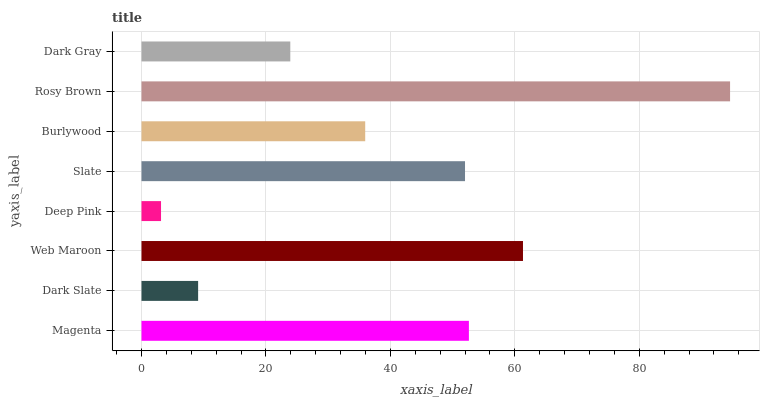Is Deep Pink the minimum?
Answer yes or no. Yes. Is Rosy Brown the maximum?
Answer yes or no. Yes. Is Dark Slate the minimum?
Answer yes or no. No. Is Dark Slate the maximum?
Answer yes or no. No. Is Magenta greater than Dark Slate?
Answer yes or no. Yes. Is Dark Slate less than Magenta?
Answer yes or no. Yes. Is Dark Slate greater than Magenta?
Answer yes or no. No. Is Magenta less than Dark Slate?
Answer yes or no. No. Is Slate the high median?
Answer yes or no. Yes. Is Burlywood the low median?
Answer yes or no. Yes. Is Dark Slate the high median?
Answer yes or no. No. Is Dark Gray the low median?
Answer yes or no. No. 